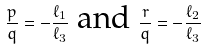Convert formula to latex. <formula><loc_0><loc_0><loc_500><loc_500>\frac { p } { q } = - \frac { \ell _ { 1 } } { \ell _ { 3 } } \text { and } \frac { r } { q } = - \frac { \ell _ { 2 } } { \ell _ { 3 } }</formula> 